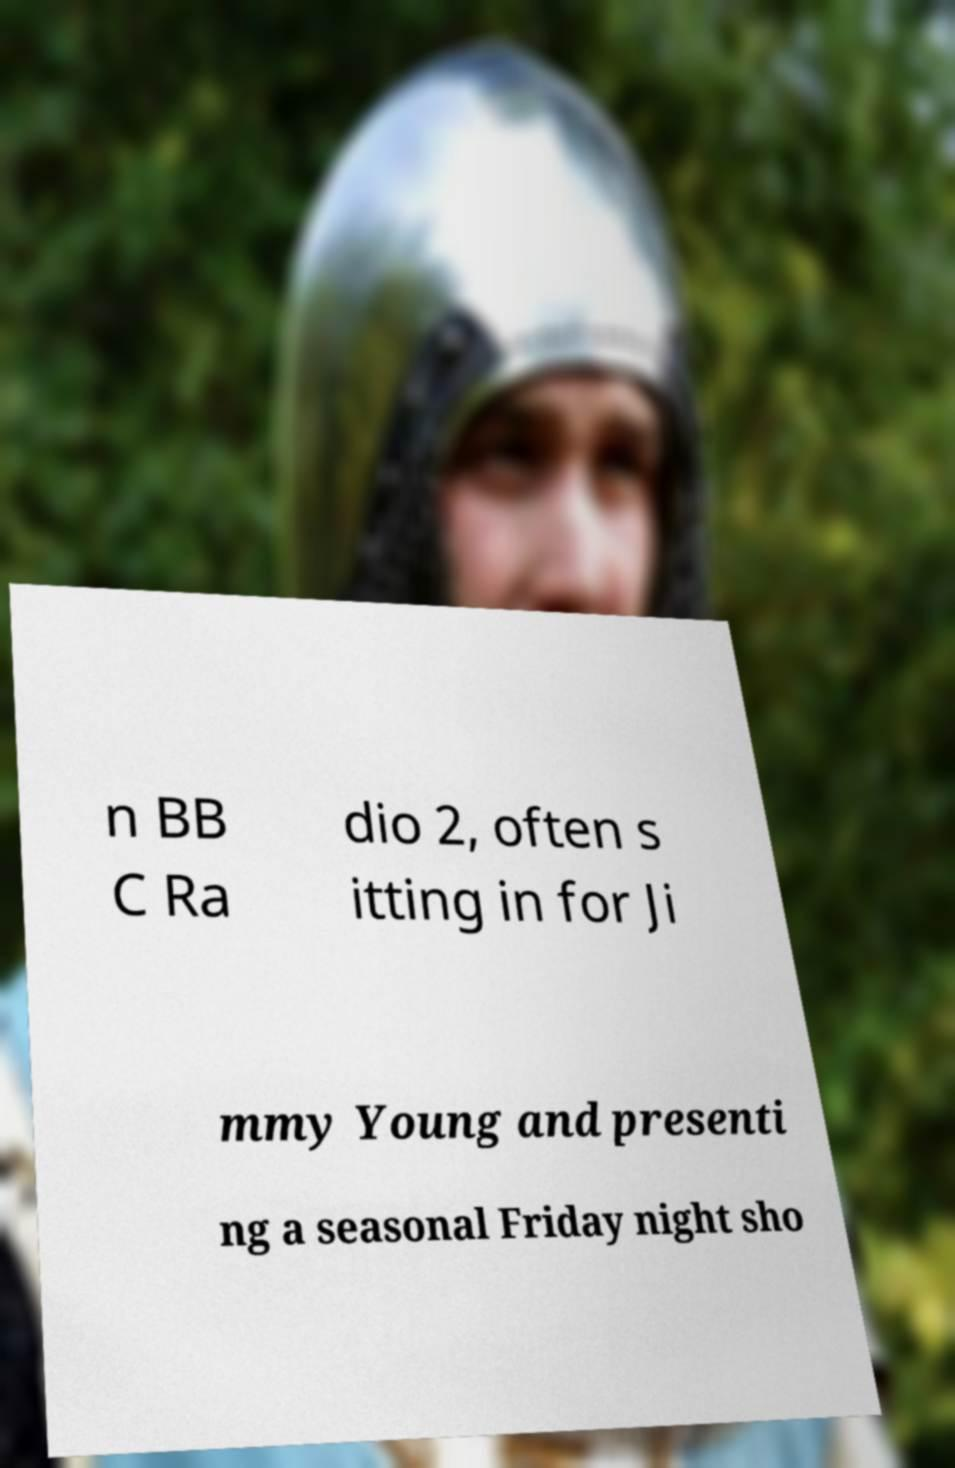There's text embedded in this image that I need extracted. Can you transcribe it verbatim? n BB C Ra dio 2, often s itting in for Ji mmy Young and presenti ng a seasonal Friday night sho 